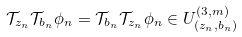<formula> <loc_0><loc_0><loc_500><loc_500>\mathcal { T } _ { z _ { n } } \mathcal { T } _ { b _ { n } } \phi _ { n } = \mathcal { T } _ { b _ { n } } \mathcal { T } _ { z _ { n } } \phi _ { n } \in U ^ { ( 3 , m ) } _ { ( z _ { n } , b _ { n } ) }</formula> 